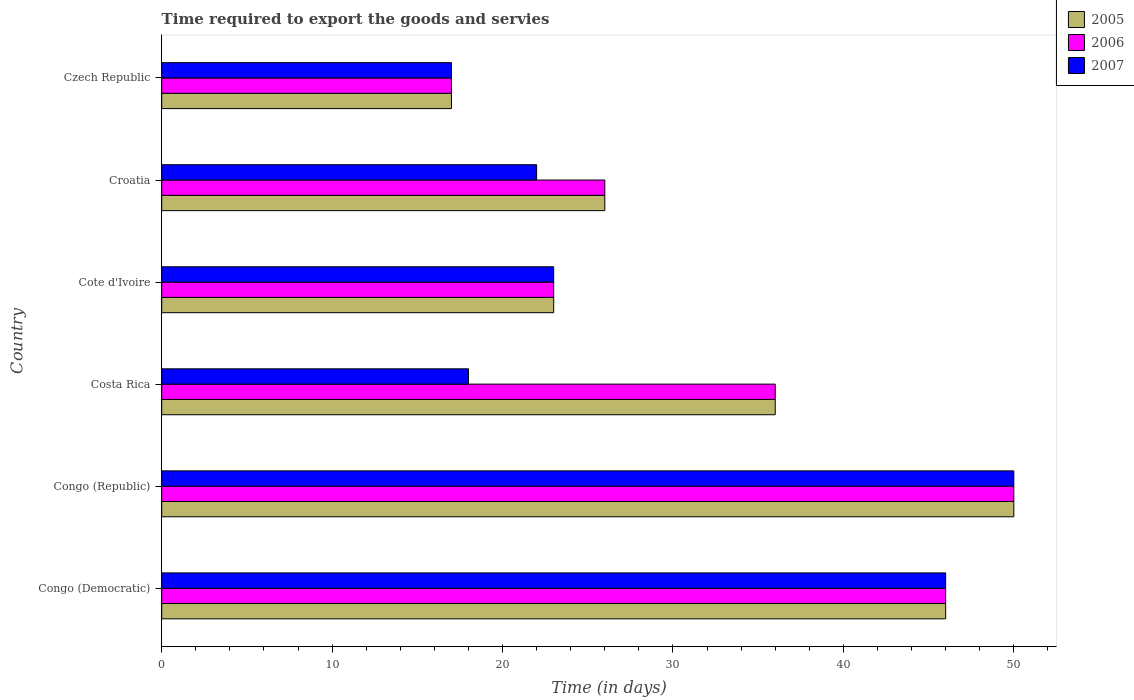How many groups of bars are there?
Provide a short and direct response. 6. Are the number of bars on each tick of the Y-axis equal?
Offer a terse response. Yes. How many bars are there on the 2nd tick from the top?
Your answer should be very brief. 3. What is the label of the 6th group of bars from the top?
Your answer should be very brief. Congo (Democratic). Across all countries, what is the maximum number of days required to export the goods and services in 2006?
Keep it short and to the point. 50. In which country was the number of days required to export the goods and services in 2005 maximum?
Give a very brief answer. Congo (Republic). In which country was the number of days required to export the goods and services in 2005 minimum?
Keep it short and to the point. Czech Republic. What is the total number of days required to export the goods and services in 2005 in the graph?
Your answer should be compact. 198. What is the difference between the number of days required to export the goods and services in 2005 in Congo (Republic) and that in Croatia?
Your answer should be compact. 24. What is the difference between the number of days required to export the goods and services in 2005 in Czech Republic and the number of days required to export the goods and services in 2007 in Costa Rica?
Ensure brevity in your answer.  -1. What is the difference between the number of days required to export the goods and services in 2007 and number of days required to export the goods and services in 2006 in Congo (Democratic)?
Your response must be concise. 0. What is the ratio of the number of days required to export the goods and services in 2005 in Congo (Democratic) to that in Czech Republic?
Offer a terse response. 2.71. Is the difference between the number of days required to export the goods and services in 2007 in Congo (Democratic) and Croatia greater than the difference between the number of days required to export the goods and services in 2006 in Congo (Democratic) and Croatia?
Your response must be concise. Yes. In how many countries, is the number of days required to export the goods and services in 2007 greater than the average number of days required to export the goods and services in 2007 taken over all countries?
Your response must be concise. 2. What does the 1st bar from the bottom in Croatia represents?
Your answer should be very brief. 2005. Is it the case that in every country, the sum of the number of days required to export the goods and services in 2007 and number of days required to export the goods and services in 2005 is greater than the number of days required to export the goods and services in 2006?
Your answer should be compact. Yes. Does the graph contain grids?
Make the answer very short. No. What is the title of the graph?
Offer a terse response. Time required to export the goods and servies. What is the label or title of the X-axis?
Provide a succinct answer. Time (in days). What is the Time (in days) in 2005 in Congo (Democratic)?
Your answer should be compact. 46. What is the Time (in days) of 2007 in Congo (Democratic)?
Give a very brief answer. 46. What is the Time (in days) in 2006 in Congo (Republic)?
Give a very brief answer. 50. What is the Time (in days) in 2007 in Costa Rica?
Your response must be concise. 18. What is the Time (in days) of 2005 in Croatia?
Ensure brevity in your answer.  26. What is the Time (in days) of 2006 in Croatia?
Your answer should be very brief. 26. What is the Time (in days) of 2007 in Croatia?
Keep it short and to the point. 22. What is the Time (in days) in 2005 in Czech Republic?
Ensure brevity in your answer.  17. What is the Time (in days) of 2007 in Czech Republic?
Make the answer very short. 17. Across all countries, what is the maximum Time (in days) in 2005?
Provide a short and direct response. 50. Across all countries, what is the maximum Time (in days) of 2006?
Keep it short and to the point. 50. Across all countries, what is the maximum Time (in days) of 2007?
Ensure brevity in your answer.  50. Across all countries, what is the minimum Time (in days) in 2006?
Your response must be concise. 17. Across all countries, what is the minimum Time (in days) in 2007?
Offer a very short reply. 17. What is the total Time (in days) of 2005 in the graph?
Provide a succinct answer. 198. What is the total Time (in days) in 2006 in the graph?
Ensure brevity in your answer.  198. What is the total Time (in days) of 2007 in the graph?
Make the answer very short. 176. What is the difference between the Time (in days) of 2006 in Congo (Democratic) and that in Congo (Republic)?
Offer a very short reply. -4. What is the difference between the Time (in days) of 2007 in Congo (Democratic) and that in Congo (Republic)?
Provide a succinct answer. -4. What is the difference between the Time (in days) in 2005 in Congo (Democratic) and that in Costa Rica?
Offer a very short reply. 10. What is the difference between the Time (in days) in 2007 in Congo (Democratic) and that in Costa Rica?
Your answer should be very brief. 28. What is the difference between the Time (in days) of 2005 in Congo (Democratic) and that in Croatia?
Your answer should be very brief. 20. What is the difference between the Time (in days) in 2007 in Congo (Democratic) and that in Croatia?
Your response must be concise. 24. What is the difference between the Time (in days) of 2006 in Congo (Democratic) and that in Czech Republic?
Offer a terse response. 29. What is the difference between the Time (in days) of 2007 in Congo (Democratic) and that in Czech Republic?
Offer a very short reply. 29. What is the difference between the Time (in days) in 2005 in Congo (Republic) and that in Costa Rica?
Your answer should be compact. 14. What is the difference between the Time (in days) in 2007 in Congo (Republic) and that in Costa Rica?
Your answer should be compact. 32. What is the difference between the Time (in days) in 2006 in Congo (Republic) and that in Cote d'Ivoire?
Provide a succinct answer. 27. What is the difference between the Time (in days) in 2007 in Congo (Republic) and that in Cote d'Ivoire?
Offer a very short reply. 27. What is the difference between the Time (in days) in 2007 in Congo (Republic) and that in Croatia?
Your answer should be compact. 28. What is the difference between the Time (in days) in 2005 in Congo (Republic) and that in Czech Republic?
Provide a succinct answer. 33. What is the difference between the Time (in days) in 2006 in Congo (Republic) and that in Czech Republic?
Offer a terse response. 33. What is the difference between the Time (in days) in 2007 in Congo (Republic) and that in Czech Republic?
Offer a very short reply. 33. What is the difference between the Time (in days) in 2006 in Costa Rica and that in Cote d'Ivoire?
Your answer should be very brief. 13. What is the difference between the Time (in days) in 2005 in Costa Rica and that in Croatia?
Provide a short and direct response. 10. What is the difference between the Time (in days) in 2006 in Costa Rica and that in Croatia?
Your answer should be compact. 10. What is the difference between the Time (in days) in 2006 in Costa Rica and that in Czech Republic?
Your response must be concise. 19. What is the difference between the Time (in days) of 2007 in Costa Rica and that in Czech Republic?
Your answer should be compact. 1. What is the difference between the Time (in days) in 2007 in Cote d'Ivoire and that in Czech Republic?
Make the answer very short. 6. What is the difference between the Time (in days) in 2005 in Croatia and that in Czech Republic?
Provide a short and direct response. 9. What is the difference between the Time (in days) of 2006 in Croatia and that in Czech Republic?
Keep it short and to the point. 9. What is the difference between the Time (in days) of 2007 in Croatia and that in Czech Republic?
Offer a very short reply. 5. What is the difference between the Time (in days) in 2005 in Congo (Democratic) and the Time (in days) in 2007 in Congo (Republic)?
Keep it short and to the point. -4. What is the difference between the Time (in days) in 2006 in Congo (Democratic) and the Time (in days) in 2007 in Congo (Republic)?
Offer a terse response. -4. What is the difference between the Time (in days) in 2005 in Congo (Democratic) and the Time (in days) in 2007 in Costa Rica?
Your answer should be very brief. 28. What is the difference between the Time (in days) of 2005 in Congo (Democratic) and the Time (in days) of 2006 in Cote d'Ivoire?
Give a very brief answer. 23. What is the difference between the Time (in days) in 2006 in Congo (Democratic) and the Time (in days) in 2007 in Cote d'Ivoire?
Ensure brevity in your answer.  23. What is the difference between the Time (in days) in 2005 in Congo (Democratic) and the Time (in days) in 2006 in Croatia?
Provide a short and direct response. 20. What is the difference between the Time (in days) in 2005 in Congo (Democratic) and the Time (in days) in 2007 in Croatia?
Your response must be concise. 24. What is the difference between the Time (in days) in 2005 in Congo (Democratic) and the Time (in days) in 2006 in Czech Republic?
Your response must be concise. 29. What is the difference between the Time (in days) of 2005 in Congo (Republic) and the Time (in days) of 2006 in Costa Rica?
Keep it short and to the point. 14. What is the difference between the Time (in days) in 2006 in Congo (Republic) and the Time (in days) in 2007 in Costa Rica?
Provide a succinct answer. 32. What is the difference between the Time (in days) in 2005 in Congo (Republic) and the Time (in days) in 2006 in Cote d'Ivoire?
Provide a succinct answer. 27. What is the difference between the Time (in days) in 2005 in Congo (Republic) and the Time (in days) in 2006 in Croatia?
Your response must be concise. 24. What is the difference between the Time (in days) of 2005 in Congo (Republic) and the Time (in days) of 2007 in Czech Republic?
Your answer should be very brief. 33. What is the difference between the Time (in days) in 2006 in Congo (Republic) and the Time (in days) in 2007 in Czech Republic?
Ensure brevity in your answer.  33. What is the difference between the Time (in days) of 2006 in Costa Rica and the Time (in days) of 2007 in Cote d'Ivoire?
Provide a short and direct response. 13. What is the difference between the Time (in days) in 2005 in Costa Rica and the Time (in days) in 2006 in Croatia?
Keep it short and to the point. 10. What is the difference between the Time (in days) of 2005 in Costa Rica and the Time (in days) of 2007 in Croatia?
Your response must be concise. 14. What is the difference between the Time (in days) in 2006 in Costa Rica and the Time (in days) in 2007 in Croatia?
Your answer should be compact. 14. What is the difference between the Time (in days) in 2006 in Costa Rica and the Time (in days) in 2007 in Czech Republic?
Offer a terse response. 19. What is the difference between the Time (in days) in 2005 in Cote d'Ivoire and the Time (in days) in 2006 in Croatia?
Provide a short and direct response. -3. What is the difference between the Time (in days) of 2005 in Cote d'Ivoire and the Time (in days) of 2007 in Croatia?
Your response must be concise. 1. What is the difference between the Time (in days) of 2005 in Cote d'Ivoire and the Time (in days) of 2007 in Czech Republic?
Offer a terse response. 6. What is the difference between the Time (in days) in 2005 in Croatia and the Time (in days) in 2006 in Czech Republic?
Your answer should be compact. 9. What is the average Time (in days) in 2007 per country?
Give a very brief answer. 29.33. What is the difference between the Time (in days) of 2005 and Time (in days) of 2007 in Congo (Democratic)?
Provide a succinct answer. 0. What is the difference between the Time (in days) in 2006 and Time (in days) in 2007 in Congo (Democratic)?
Offer a very short reply. 0. What is the difference between the Time (in days) of 2005 and Time (in days) of 2007 in Congo (Republic)?
Your answer should be compact. 0. What is the difference between the Time (in days) of 2006 and Time (in days) of 2007 in Congo (Republic)?
Your answer should be very brief. 0. What is the difference between the Time (in days) in 2005 and Time (in days) in 2006 in Costa Rica?
Keep it short and to the point. 0. What is the difference between the Time (in days) of 2005 and Time (in days) of 2007 in Costa Rica?
Offer a terse response. 18. What is the difference between the Time (in days) of 2006 and Time (in days) of 2007 in Costa Rica?
Your answer should be compact. 18. What is the difference between the Time (in days) of 2005 and Time (in days) of 2007 in Cote d'Ivoire?
Offer a very short reply. 0. What is the difference between the Time (in days) in 2005 and Time (in days) in 2006 in Czech Republic?
Make the answer very short. 0. What is the difference between the Time (in days) in 2005 and Time (in days) in 2007 in Czech Republic?
Make the answer very short. 0. What is the difference between the Time (in days) in 2006 and Time (in days) in 2007 in Czech Republic?
Make the answer very short. 0. What is the ratio of the Time (in days) in 2005 in Congo (Democratic) to that in Congo (Republic)?
Ensure brevity in your answer.  0.92. What is the ratio of the Time (in days) in 2006 in Congo (Democratic) to that in Congo (Republic)?
Your response must be concise. 0.92. What is the ratio of the Time (in days) of 2005 in Congo (Democratic) to that in Costa Rica?
Provide a short and direct response. 1.28. What is the ratio of the Time (in days) of 2006 in Congo (Democratic) to that in Costa Rica?
Ensure brevity in your answer.  1.28. What is the ratio of the Time (in days) in 2007 in Congo (Democratic) to that in Costa Rica?
Ensure brevity in your answer.  2.56. What is the ratio of the Time (in days) of 2005 in Congo (Democratic) to that in Cote d'Ivoire?
Ensure brevity in your answer.  2. What is the ratio of the Time (in days) in 2007 in Congo (Democratic) to that in Cote d'Ivoire?
Ensure brevity in your answer.  2. What is the ratio of the Time (in days) in 2005 in Congo (Democratic) to that in Croatia?
Offer a very short reply. 1.77. What is the ratio of the Time (in days) of 2006 in Congo (Democratic) to that in Croatia?
Offer a terse response. 1.77. What is the ratio of the Time (in days) in 2007 in Congo (Democratic) to that in Croatia?
Give a very brief answer. 2.09. What is the ratio of the Time (in days) of 2005 in Congo (Democratic) to that in Czech Republic?
Your response must be concise. 2.71. What is the ratio of the Time (in days) in 2006 in Congo (Democratic) to that in Czech Republic?
Your answer should be very brief. 2.71. What is the ratio of the Time (in days) in 2007 in Congo (Democratic) to that in Czech Republic?
Give a very brief answer. 2.71. What is the ratio of the Time (in days) of 2005 in Congo (Republic) to that in Costa Rica?
Provide a short and direct response. 1.39. What is the ratio of the Time (in days) in 2006 in Congo (Republic) to that in Costa Rica?
Ensure brevity in your answer.  1.39. What is the ratio of the Time (in days) in 2007 in Congo (Republic) to that in Costa Rica?
Give a very brief answer. 2.78. What is the ratio of the Time (in days) of 2005 in Congo (Republic) to that in Cote d'Ivoire?
Offer a very short reply. 2.17. What is the ratio of the Time (in days) of 2006 in Congo (Republic) to that in Cote d'Ivoire?
Your answer should be very brief. 2.17. What is the ratio of the Time (in days) of 2007 in Congo (Republic) to that in Cote d'Ivoire?
Offer a very short reply. 2.17. What is the ratio of the Time (in days) of 2005 in Congo (Republic) to that in Croatia?
Your answer should be very brief. 1.92. What is the ratio of the Time (in days) of 2006 in Congo (Republic) to that in Croatia?
Provide a succinct answer. 1.92. What is the ratio of the Time (in days) in 2007 in Congo (Republic) to that in Croatia?
Ensure brevity in your answer.  2.27. What is the ratio of the Time (in days) of 2005 in Congo (Republic) to that in Czech Republic?
Keep it short and to the point. 2.94. What is the ratio of the Time (in days) of 2006 in Congo (Republic) to that in Czech Republic?
Provide a short and direct response. 2.94. What is the ratio of the Time (in days) in 2007 in Congo (Republic) to that in Czech Republic?
Your response must be concise. 2.94. What is the ratio of the Time (in days) in 2005 in Costa Rica to that in Cote d'Ivoire?
Your answer should be compact. 1.57. What is the ratio of the Time (in days) of 2006 in Costa Rica to that in Cote d'Ivoire?
Provide a short and direct response. 1.57. What is the ratio of the Time (in days) in 2007 in Costa Rica to that in Cote d'Ivoire?
Offer a terse response. 0.78. What is the ratio of the Time (in days) in 2005 in Costa Rica to that in Croatia?
Provide a short and direct response. 1.38. What is the ratio of the Time (in days) of 2006 in Costa Rica to that in Croatia?
Provide a short and direct response. 1.38. What is the ratio of the Time (in days) of 2007 in Costa Rica to that in Croatia?
Ensure brevity in your answer.  0.82. What is the ratio of the Time (in days) in 2005 in Costa Rica to that in Czech Republic?
Give a very brief answer. 2.12. What is the ratio of the Time (in days) of 2006 in Costa Rica to that in Czech Republic?
Keep it short and to the point. 2.12. What is the ratio of the Time (in days) in 2007 in Costa Rica to that in Czech Republic?
Give a very brief answer. 1.06. What is the ratio of the Time (in days) in 2005 in Cote d'Ivoire to that in Croatia?
Give a very brief answer. 0.88. What is the ratio of the Time (in days) of 2006 in Cote d'Ivoire to that in Croatia?
Offer a terse response. 0.88. What is the ratio of the Time (in days) of 2007 in Cote d'Ivoire to that in Croatia?
Keep it short and to the point. 1.05. What is the ratio of the Time (in days) of 2005 in Cote d'Ivoire to that in Czech Republic?
Make the answer very short. 1.35. What is the ratio of the Time (in days) of 2006 in Cote d'Ivoire to that in Czech Republic?
Offer a terse response. 1.35. What is the ratio of the Time (in days) of 2007 in Cote d'Ivoire to that in Czech Republic?
Make the answer very short. 1.35. What is the ratio of the Time (in days) of 2005 in Croatia to that in Czech Republic?
Keep it short and to the point. 1.53. What is the ratio of the Time (in days) in 2006 in Croatia to that in Czech Republic?
Provide a short and direct response. 1.53. What is the ratio of the Time (in days) in 2007 in Croatia to that in Czech Republic?
Provide a short and direct response. 1.29. What is the difference between the highest and the second highest Time (in days) in 2006?
Your response must be concise. 4. What is the difference between the highest and the second highest Time (in days) of 2007?
Keep it short and to the point. 4. What is the difference between the highest and the lowest Time (in days) in 2007?
Give a very brief answer. 33. 